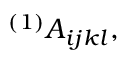<formula> <loc_0><loc_0><loc_500><loc_500>^ { ( 1 ) } A _ { i j k l } ,</formula> 